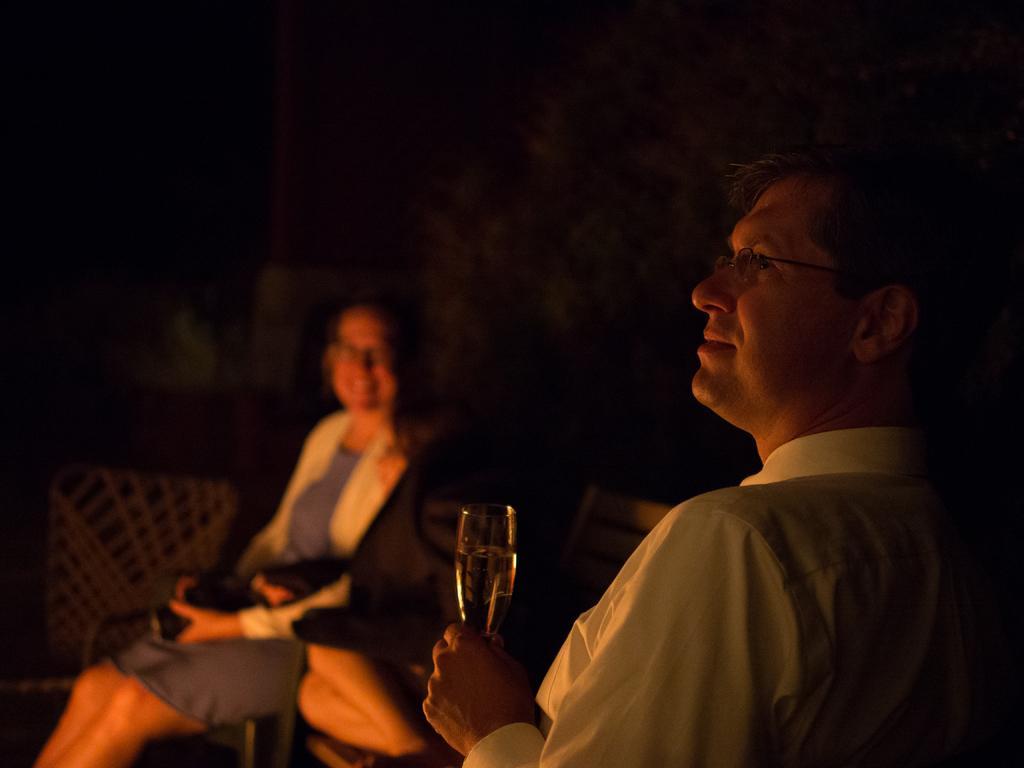In one or two sentences, can you explain what this image depicts? I can see in this image a man and a woman are sitting, the person on the right side is holding a glass in his hand and wearing a white shirt and spectacles. 